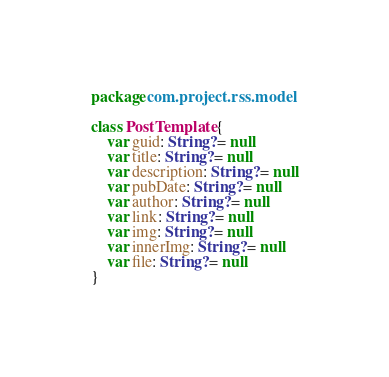<code> <loc_0><loc_0><loc_500><loc_500><_Kotlin_>package com.project.rss.model

class PostTemplate {
    var guid: String? = null
    var title: String? = null
    var description: String? = null
    var pubDate: String? = null
    var author: String? = null
    var link: String? = null
    var img: String? = null
    var innerImg: String? = null
    var file: String? = null
}</code> 